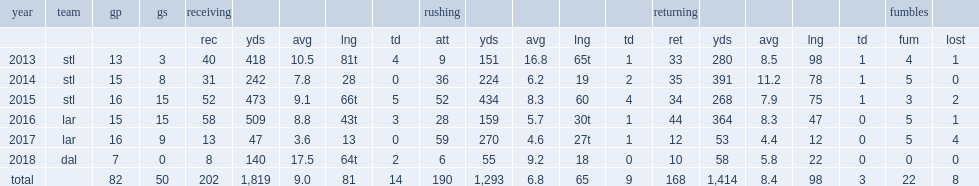How many rushing yards did tavon austin record in 2016? 159.0. 